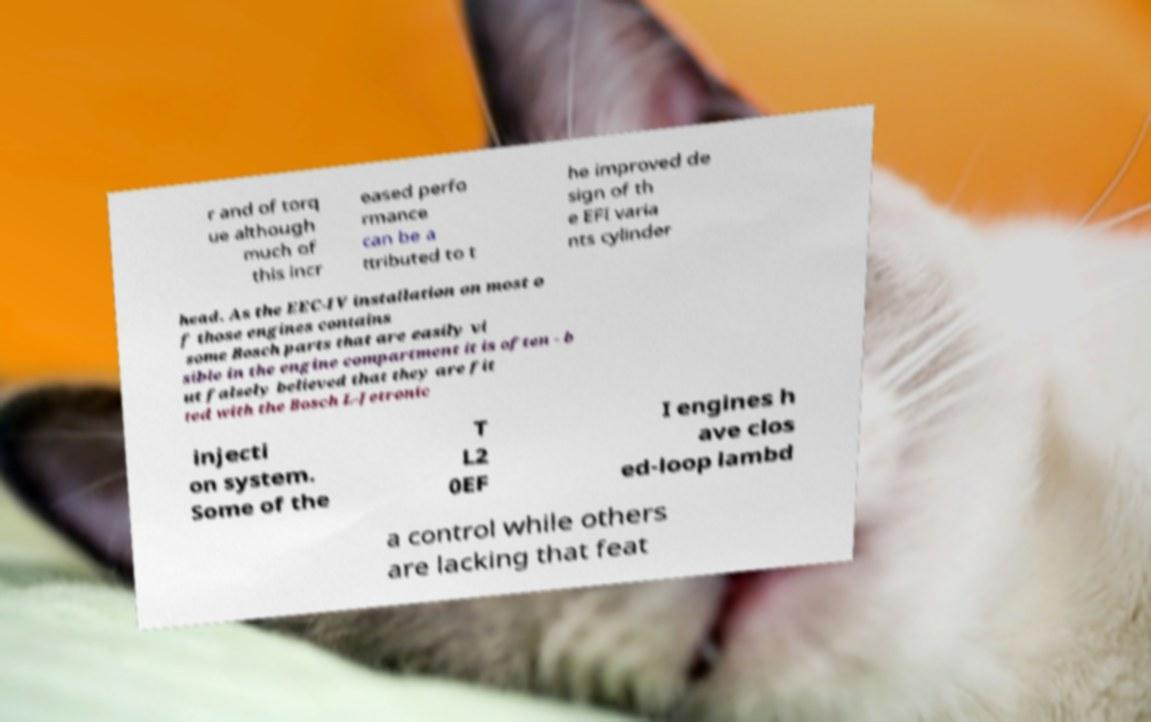For documentation purposes, I need the text within this image transcribed. Could you provide that? r and of torq ue although much of this incr eased perfo rmance can be a ttributed to t he improved de sign of th e EFI varia nts cylinder head. As the EEC-IV installation on most o f those engines contains some Bosch parts that are easily vi sible in the engine compartment it is often - b ut falsely believed that they are fit ted with the Bosch L-Jetronic injecti on system. Some of the T L2 0EF I engines h ave clos ed-loop lambd a control while others are lacking that feat 